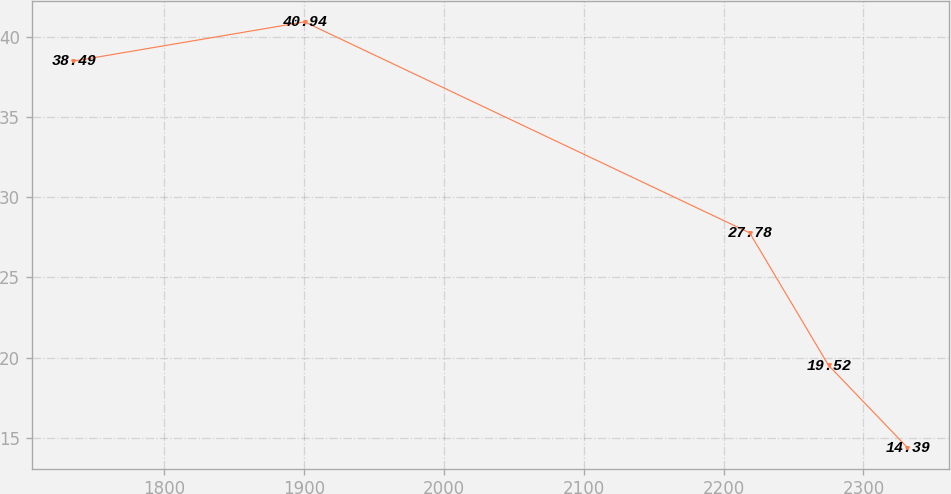Convert chart. <chart><loc_0><loc_0><loc_500><loc_500><line_chart><ecel><fcel>Unnamed: 1<nl><fcel>1734.93<fcel>38.49<nl><fcel>1900.28<fcel>40.94<nl><fcel>2218.65<fcel>27.78<nl><fcel>2275.03<fcel>19.52<nl><fcel>2331.41<fcel>14.39<nl></chart> 